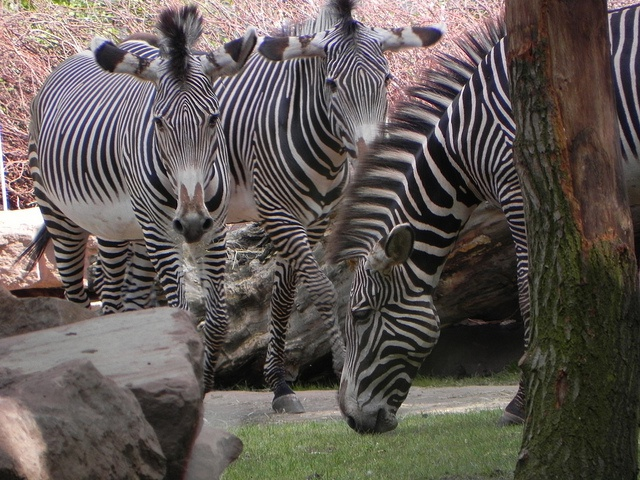Describe the objects in this image and their specific colors. I can see zebra in gray, black, and darkgray tones, zebra in gray, darkgray, black, and lightgray tones, and zebra in gray, black, darkgray, and lightgray tones in this image. 